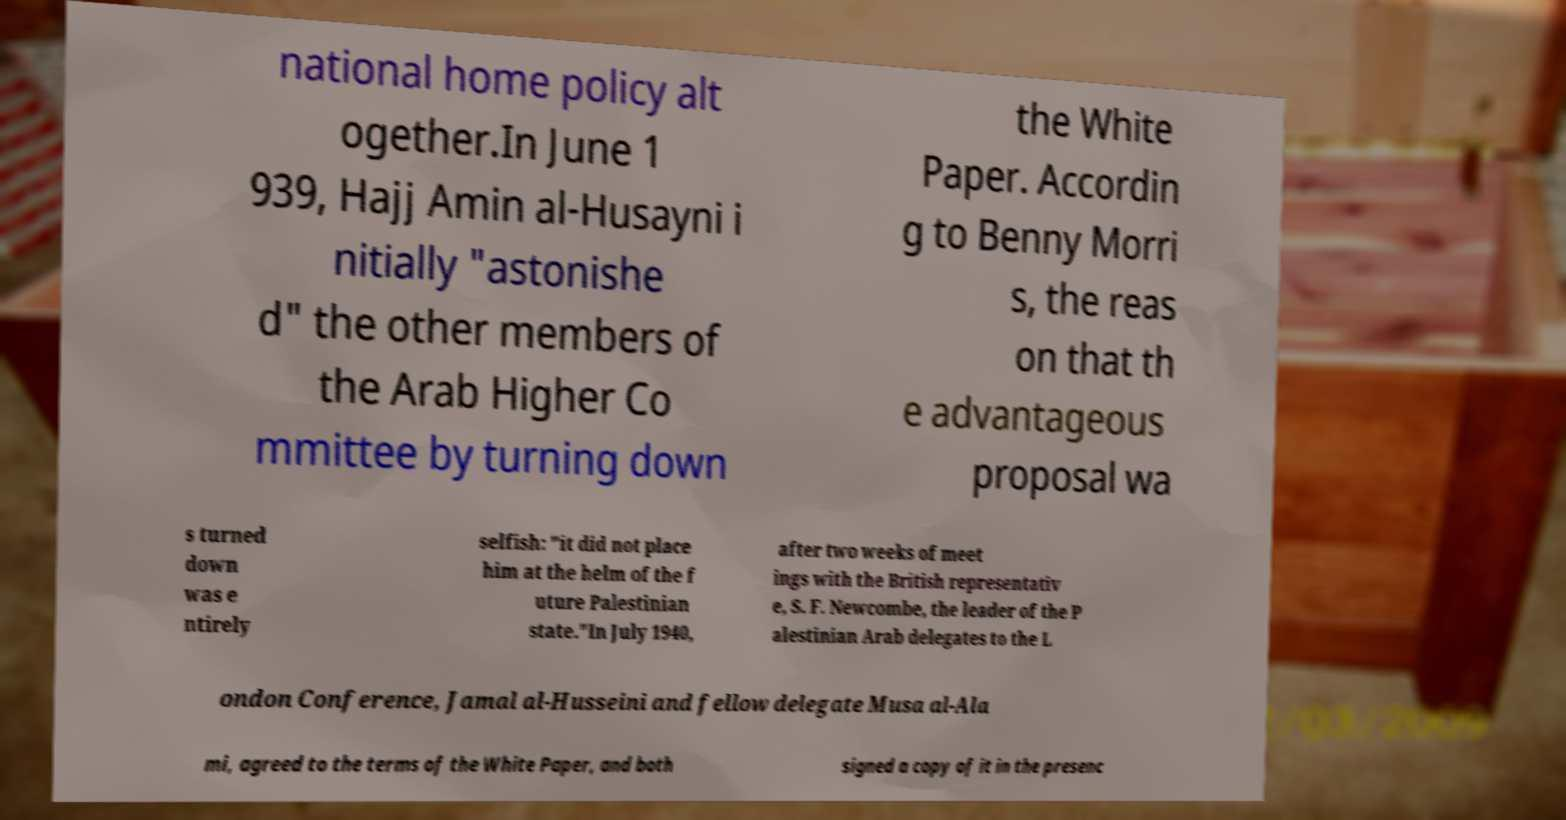Could you assist in decoding the text presented in this image and type it out clearly? national home policy alt ogether.In June 1 939, Hajj Amin al-Husayni i nitially "astonishe d" the other members of the Arab Higher Co mmittee by turning down the White Paper. Accordin g to Benny Morri s, the reas on that th e advantageous proposal wa s turned down was e ntirely selfish: "it did not place him at the helm of the f uture Palestinian state."In July 1940, after two weeks of meet ings with the British representativ e, S. F. Newcombe, the leader of the P alestinian Arab delegates to the L ondon Conference, Jamal al-Husseini and fellow delegate Musa al-Ala mi, agreed to the terms of the White Paper, and both signed a copy of it in the presenc 